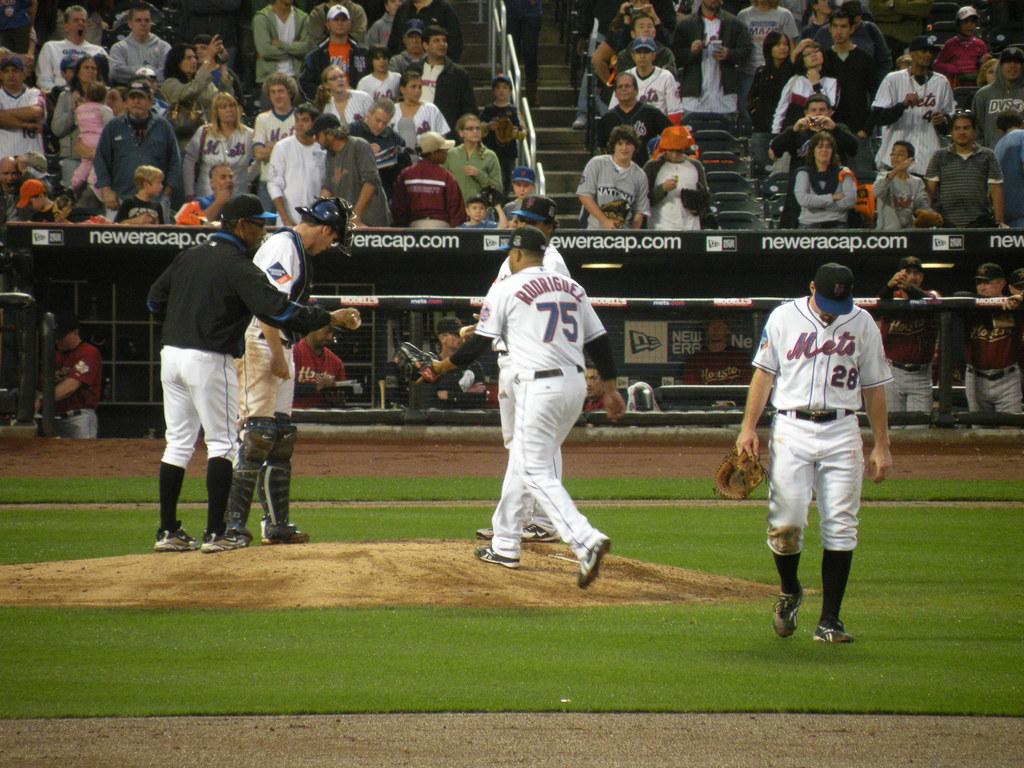What are the players' numbers?
Keep it short and to the point. 75 and 28. What team is this?
Offer a very short reply. Mets. 